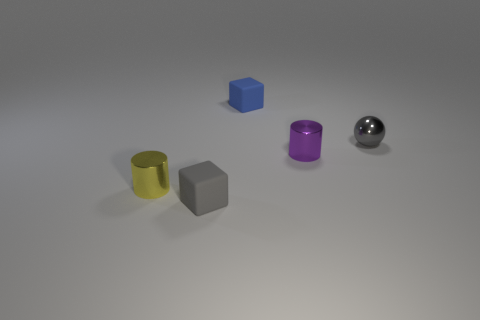Add 1 tiny purple cylinders. How many objects exist? 6 Subtract all yellow cylinders. How many cylinders are left? 1 Subtract 1 cylinders. How many cylinders are left? 1 Add 3 purple metal cylinders. How many purple metal cylinders are left? 4 Add 4 objects. How many objects exist? 9 Subtract 1 purple cylinders. How many objects are left? 4 Subtract all cubes. How many objects are left? 3 Subtract all blue balls. Subtract all purple cubes. How many balls are left? 1 Subtract all brown balls. How many purple blocks are left? 0 Subtract all large red rubber cylinders. Subtract all small metallic balls. How many objects are left? 4 